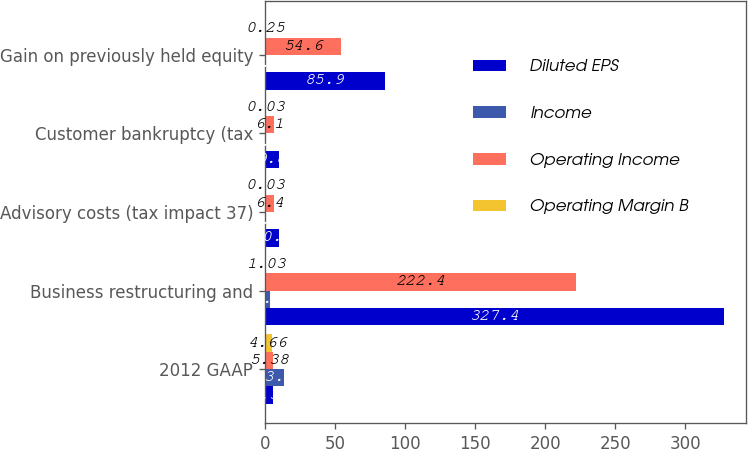<chart> <loc_0><loc_0><loc_500><loc_500><stacked_bar_chart><ecel><fcel>2012 GAAP<fcel>Business restructuring and<fcel>Advisory costs (tax impact 37)<fcel>Customer bankruptcy (tax<fcel>Gain on previously held equity<nl><fcel>Diluted EPS<fcel>5.38<fcel>327.4<fcel>10.1<fcel>9.8<fcel>85.9<nl><fcel>Income<fcel>13.3<fcel>3.5<fcel>0.1<fcel>0.1<fcel>0.9<nl><fcel>Operating Income<fcel>5.38<fcel>222.4<fcel>6.4<fcel>6.1<fcel>54.6<nl><fcel>Operating Margin B<fcel>4.66<fcel>1.03<fcel>0.03<fcel>0.03<fcel>0.25<nl></chart> 